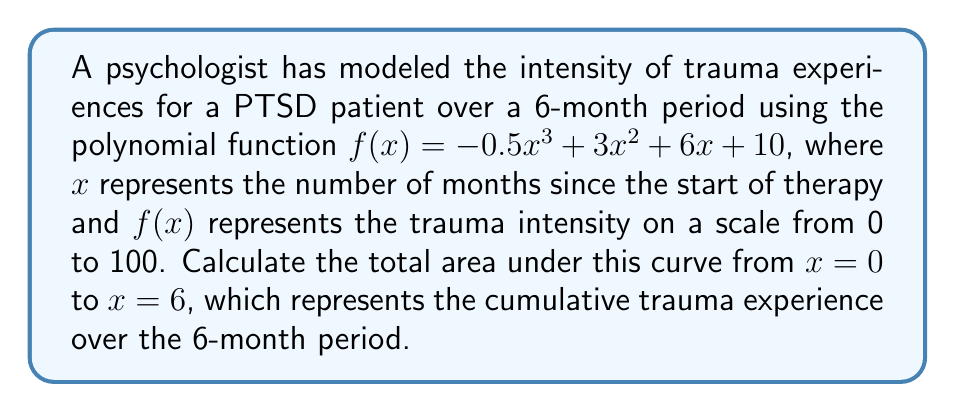Solve this math problem. To find the area under the curve, we need to calculate the definite integral of the function from 0 to 6.

1) The integral of $f(x) = -0.5x^3 + 3x^2 + 6x + 10$ is:
   $$F(x) = -\frac{1}{8}x^4 + x^3 + 3x^2 + 10x + C$$

2) We need to evaluate $\int_0^6 f(x) dx = F(6) - F(0)$

3) Calculate $F(6)$:
   $$F(6) = -\frac{1}{8}(6^4) + 6^3 + 3(6^2) + 10(6) = -81 + 216 + 108 + 60 = 303$$

4) Calculate $F(0)$:
   $$F(0) = -\frac{1}{8}(0^4) + 0^3 + 3(0^2) + 10(0) = 0$$

5) The area is the difference:
   $$\text{Area} = F(6) - F(0) = 303 - 0 = 303$$

Therefore, the total area under the curve, representing the cumulative trauma experience over the 6-month period, is 303 units.
Answer: 303 units 